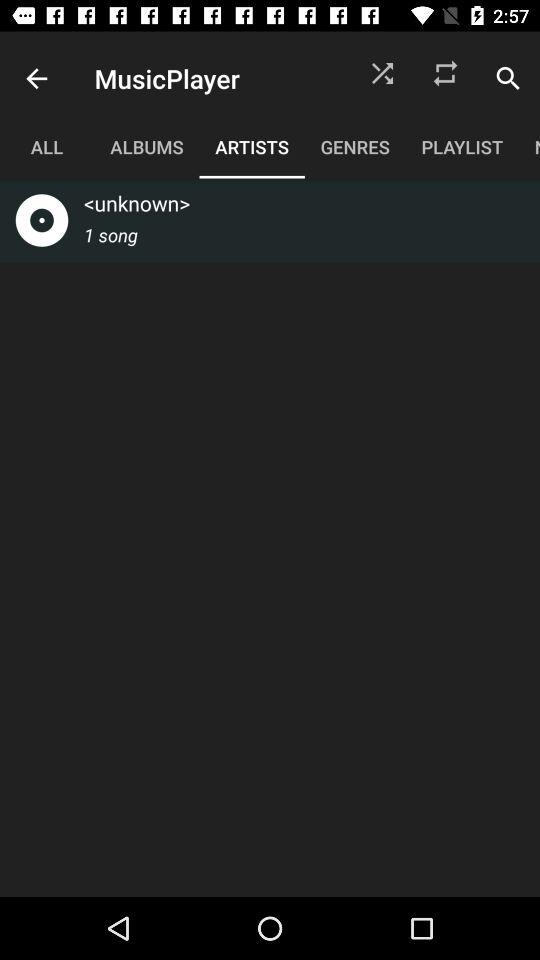How many notifications are there in "ALL"?
When the provided information is insufficient, respond with <no answer>. <no answer> 